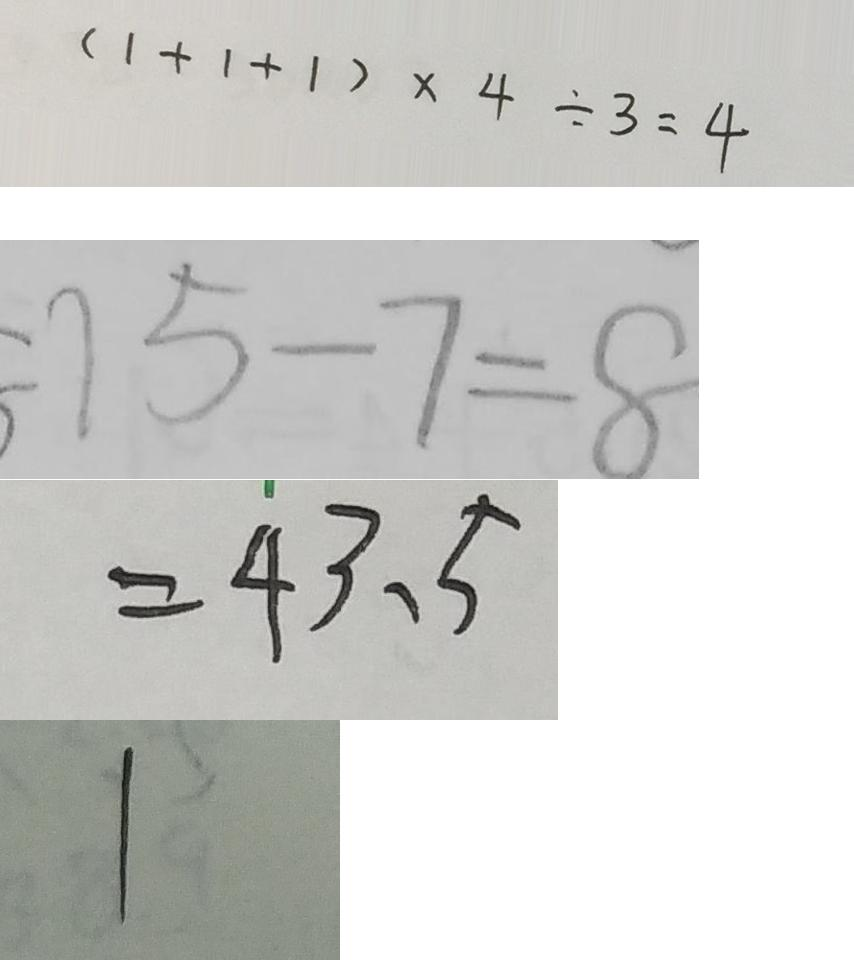Convert formula to latex. <formula><loc_0><loc_0><loc_500><loc_500>( 1 + 1 + 1 ) \times 4 \div 3 = 4 
 = 1 5 - 7 = 8 
 = 4 3 . 5 
 1</formula> 